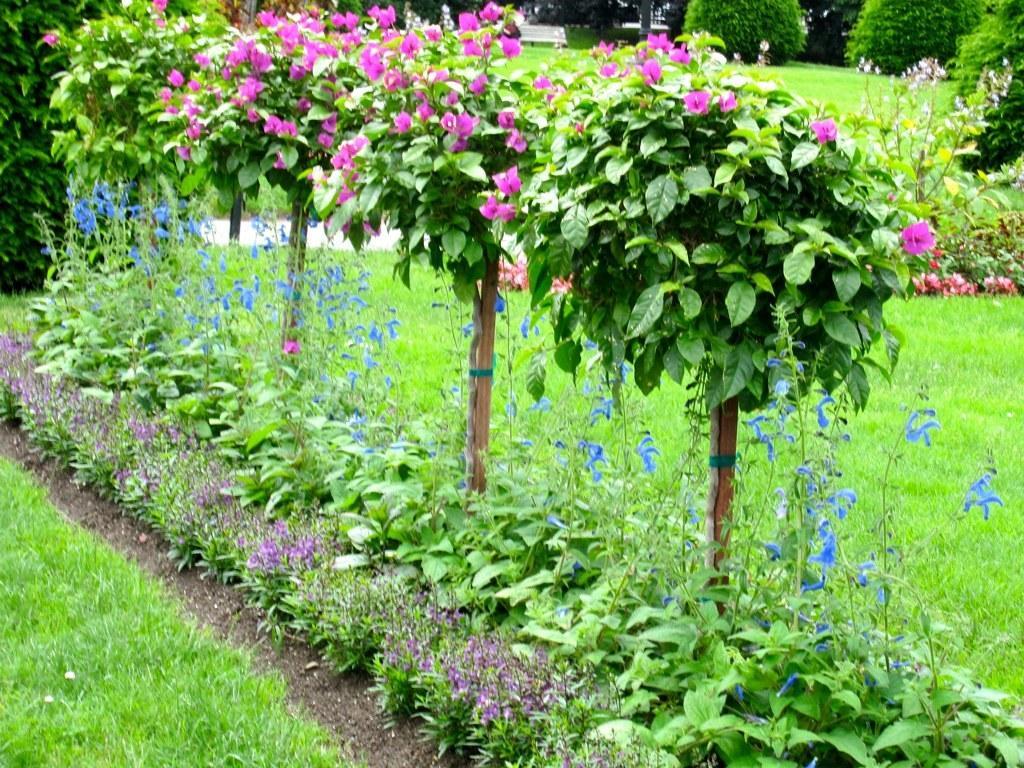Describe this image in one or two sentences. In this image there is beautiful garden with flowers, small plants and grass. 